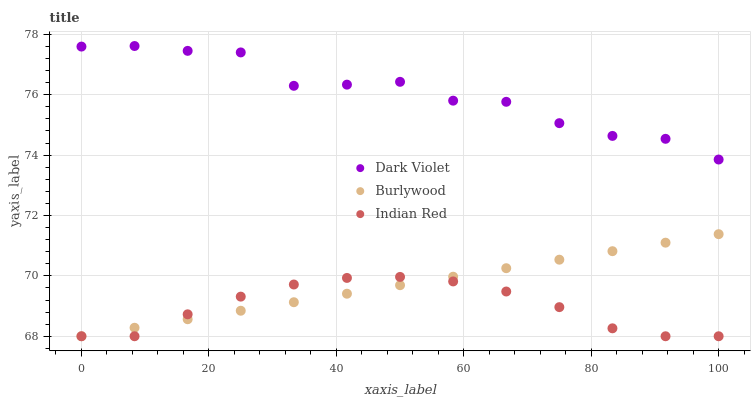Does Indian Red have the minimum area under the curve?
Answer yes or no. Yes. Does Dark Violet have the maximum area under the curve?
Answer yes or no. Yes. Does Dark Violet have the minimum area under the curve?
Answer yes or no. No. Does Indian Red have the maximum area under the curve?
Answer yes or no. No. Is Burlywood the smoothest?
Answer yes or no. Yes. Is Dark Violet the roughest?
Answer yes or no. Yes. Is Indian Red the smoothest?
Answer yes or no. No. Is Indian Red the roughest?
Answer yes or no. No. Does Burlywood have the lowest value?
Answer yes or no. Yes. Does Dark Violet have the lowest value?
Answer yes or no. No. Does Dark Violet have the highest value?
Answer yes or no. Yes. Does Indian Red have the highest value?
Answer yes or no. No. Is Indian Red less than Dark Violet?
Answer yes or no. Yes. Is Dark Violet greater than Burlywood?
Answer yes or no. Yes. Does Burlywood intersect Indian Red?
Answer yes or no. Yes. Is Burlywood less than Indian Red?
Answer yes or no. No. Is Burlywood greater than Indian Red?
Answer yes or no. No. Does Indian Red intersect Dark Violet?
Answer yes or no. No. 